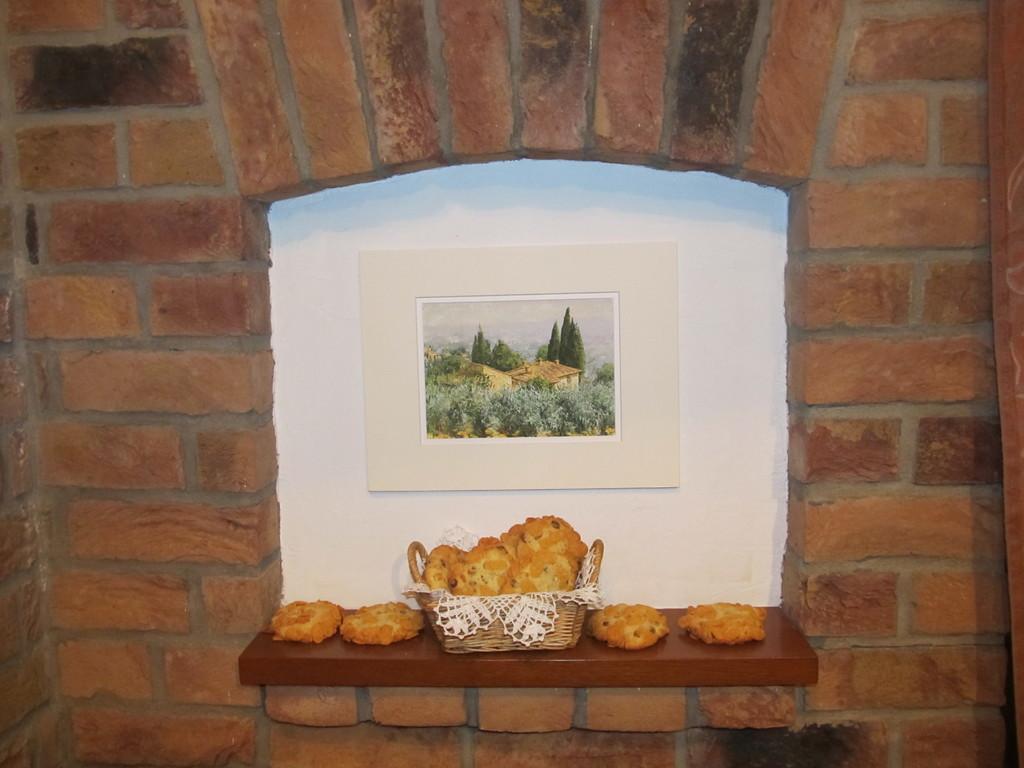Describe this image in one or two sentences. This image is taken indoors. In this image there is a wall with a picture frame on it and there is a shelf. On the shelf there is a basket with a few cookies. 